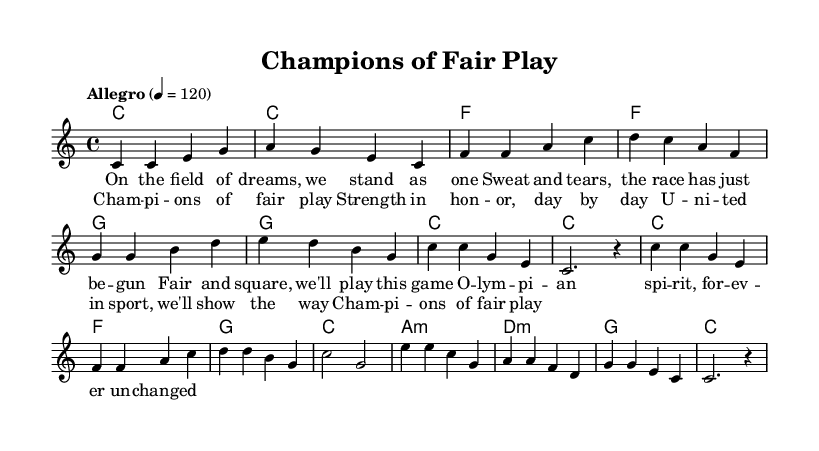What is the key signature of this music? The key signature listed in the global section indicates C major, which has no sharps or flats.
Answer: C major What is the time signature of this music? The time signature found in the global section is 4/4, which indicates that there are four beats in each measure.
Answer: 4/4 What is the tempo marking for this piece? According to the global section, the tempo marking is "Allegro" with a speed indication of quarter note equals 120 beats per minute.
Answer: Allegro How many measures are in the verse? By counting the measures in the melody section, there are eight measures in the designated verse part.
Answer: Eight What is the first lyric of the chorus? The first lyric of the chorus, as specified in the lyrics section, is "Champions of fair play".
Answer: Champions of fair play What chord is played during the first measure of the verse? The chord indicated in the harmonies section for the first measure of the verse is C major, noted as "c1".
Answer: C What is the structure of the music based on the lyrics? The structure of the music combines a verse followed by a chorus, repeating this pattern to convey the themes of sportsmanship and unity.
Answer: Verse and chorus 